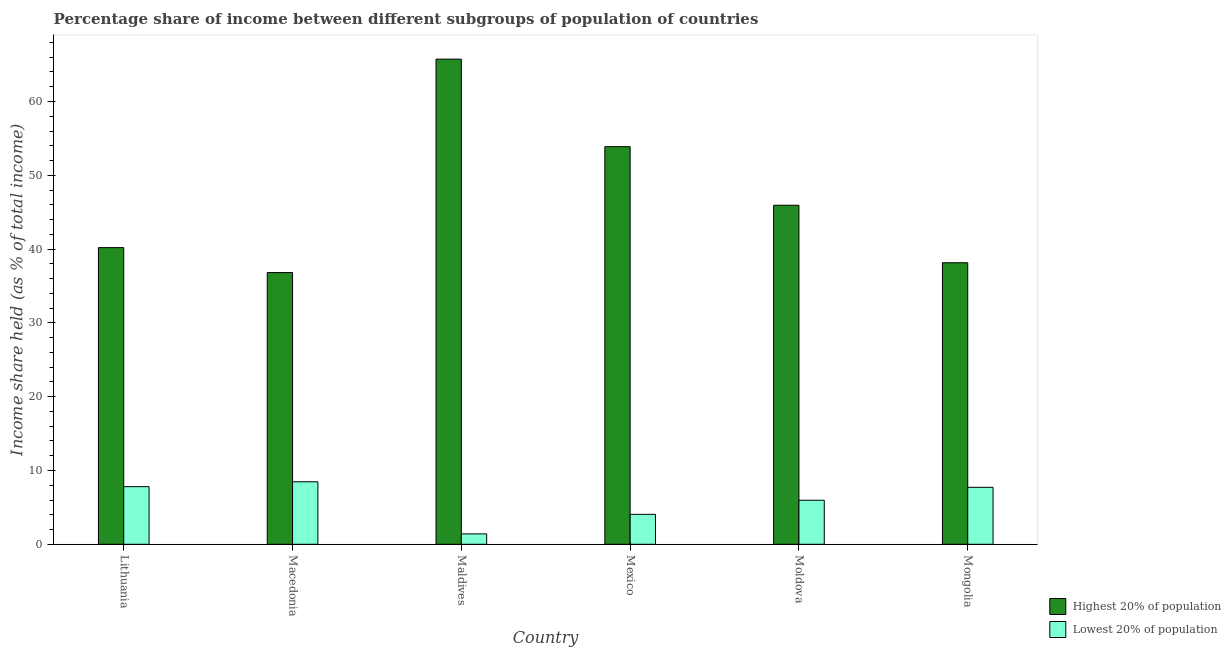How many different coloured bars are there?
Your answer should be very brief. 2. Are the number of bars on each tick of the X-axis equal?
Your answer should be very brief. Yes. How many bars are there on the 1st tick from the left?
Your answer should be very brief. 2. What is the label of the 3rd group of bars from the left?
Provide a succinct answer. Maldives. In how many cases, is the number of bars for a given country not equal to the number of legend labels?
Give a very brief answer. 0. What is the income share held by lowest 20% of the population in Macedonia?
Your answer should be very brief. 8.47. Across all countries, what is the maximum income share held by highest 20% of the population?
Offer a very short reply. 65.74. Across all countries, what is the minimum income share held by highest 20% of the population?
Your answer should be compact. 36.82. In which country was the income share held by lowest 20% of the population maximum?
Your answer should be very brief. Macedonia. In which country was the income share held by highest 20% of the population minimum?
Ensure brevity in your answer.  Macedonia. What is the total income share held by highest 20% of the population in the graph?
Make the answer very short. 280.73. What is the difference between the income share held by lowest 20% of the population in Maldives and that in Moldova?
Provide a short and direct response. -4.56. What is the difference between the income share held by lowest 20% of the population in Mexico and the income share held by highest 20% of the population in Macedonia?
Offer a terse response. -32.76. What is the average income share held by lowest 20% of the population per country?
Keep it short and to the point. 5.91. What is the difference between the income share held by lowest 20% of the population and income share held by highest 20% of the population in Mexico?
Keep it short and to the point. -49.82. What is the ratio of the income share held by highest 20% of the population in Lithuania to that in Moldova?
Ensure brevity in your answer.  0.88. Is the difference between the income share held by highest 20% of the population in Macedonia and Mexico greater than the difference between the income share held by lowest 20% of the population in Macedonia and Mexico?
Provide a succinct answer. No. What is the difference between the highest and the second highest income share held by highest 20% of the population?
Give a very brief answer. 11.86. What is the difference between the highest and the lowest income share held by highest 20% of the population?
Your answer should be compact. 28.92. In how many countries, is the income share held by highest 20% of the population greater than the average income share held by highest 20% of the population taken over all countries?
Ensure brevity in your answer.  2. What does the 1st bar from the left in Macedonia represents?
Provide a short and direct response. Highest 20% of population. What does the 1st bar from the right in Mexico represents?
Ensure brevity in your answer.  Lowest 20% of population. Are the values on the major ticks of Y-axis written in scientific E-notation?
Provide a succinct answer. No. Does the graph contain grids?
Offer a very short reply. No. Where does the legend appear in the graph?
Give a very brief answer. Bottom right. What is the title of the graph?
Offer a terse response. Percentage share of income between different subgroups of population of countries. Does "Quasi money growth" appear as one of the legend labels in the graph?
Ensure brevity in your answer.  No. What is the label or title of the X-axis?
Give a very brief answer. Country. What is the label or title of the Y-axis?
Give a very brief answer. Income share held (as % of total income). What is the Income share held (as % of total income) in Highest 20% of population in Lithuania?
Offer a terse response. 40.2. What is the Income share held (as % of total income) of Lowest 20% of population in Lithuania?
Give a very brief answer. 7.81. What is the Income share held (as % of total income) of Highest 20% of population in Macedonia?
Give a very brief answer. 36.82. What is the Income share held (as % of total income) of Lowest 20% of population in Macedonia?
Give a very brief answer. 8.47. What is the Income share held (as % of total income) in Highest 20% of population in Maldives?
Provide a short and direct response. 65.74. What is the Income share held (as % of total income) of Lowest 20% of population in Maldives?
Your answer should be very brief. 1.41. What is the Income share held (as % of total income) in Highest 20% of population in Mexico?
Offer a terse response. 53.88. What is the Income share held (as % of total income) in Lowest 20% of population in Mexico?
Your answer should be compact. 4.06. What is the Income share held (as % of total income) of Highest 20% of population in Moldova?
Keep it short and to the point. 45.94. What is the Income share held (as % of total income) in Lowest 20% of population in Moldova?
Your answer should be compact. 5.97. What is the Income share held (as % of total income) of Highest 20% of population in Mongolia?
Your answer should be very brief. 38.15. What is the Income share held (as % of total income) of Lowest 20% of population in Mongolia?
Make the answer very short. 7.72. Across all countries, what is the maximum Income share held (as % of total income) in Highest 20% of population?
Make the answer very short. 65.74. Across all countries, what is the maximum Income share held (as % of total income) in Lowest 20% of population?
Keep it short and to the point. 8.47. Across all countries, what is the minimum Income share held (as % of total income) of Highest 20% of population?
Make the answer very short. 36.82. Across all countries, what is the minimum Income share held (as % of total income) of Lowest 20% of population?
Provide a short and direct response. 1.41. What is the total Income share held (as % of total income) of Highest 20% of population in the graph?
Offer a very short reply. 280.73. What is the total Income share held (as % of total income) in Lowest 20% of population in the graph?
Provide a short and direct response. 35.44. What is the difference between the Income share held (as % of total income) of Highest 20% of population in Lithuania and that in Macedonia?
Your response must be concise. 3.38. What is the difference between the Income share held (as % of total income) in Lowest 20% of population in Lithuania and that in Macedonia?
Your answer should be compact. -0.66. What is the difference between the Income share held (as % of total income) of Highest 20% of population in Lithuania and that in Maldives?
Your response must be concise. -25.54. What is the difference between the Income share held (as % of total income) in Lowest 20% of population in Lithuania and that in Maldives?
Give a very brief answer. 6.4. What is the difference between the Income share held (as % of total income) of Highest 20% of population in Lithuania and that in Mexico?
Your answer should be compact. -13.68. What is the difference between the Income share held (as % of total income) in Lowest 20% of population in Lithuania and that in Mexico?
Your answer should be compact. 3.75. What is the difference between the Income share held (as % of total income) of Highest 20% of population in Lithuania and that in Moldova?
Make the answer very short. -5.74. What is the difference between the Income share held (as % of total income) of Lowest 20% of population in Lithuania and that in Moldova?
Provide a succinct answer. 1.84. What is the difference between the Income share held (as % of total income) in Highest 20% of population in Lithuania and that in Mongolia?
Keep it short and to the point. 2.05. What is the difference between the Income share held (as % of total income) in Lowest 20% of population in Lithuania and that in Mongolia?
Your response must be concise. 0.09. What is the difference between the Income share held (as % of total income) of Highest 20% of population in Macedonia and that in Maldives?
Ensure brevity in your answer.  -28.92. What is the difference between the Income share held (as % of total income) in Lowest 20% of population in Macedonia and that in Maldives?
Your answer should be compact. 7.06. What is the difference between the Income share held (as % of total income) in Highest 20% of population in Macedonia and that in Mexico?
Ensure brevity in your answer.  -17.06. What is the difference between the Income share held (as % of total income) in Lowest 20% of population in Macedonia and that in Mexico?
Keep it short and to the point. 4.41. What is the difference between the Income share held (as % of total income) in Highest 20% of population in Macedonia and that in Moldova?
Offer a very short reply. -9.12. What is the difference between the Income share held (as % of total income) in Lowest 20% of population in Macedonia and that in Moldova?
Ensure brevity in your answer.  2.5. What is the difference between the Income share held (as % of total income) of Highest 20% of population in Macedonia and that in Mongolia?
Give a very brief answer. -1.33. What is the difference between the Income share held (as % of total income) of Lowest 20% of population in Macedonia and that in Mongolia?
Offer a terse response. 0.75. What is the difference between the Income share held (as % of total income) in Highest 20% of population in Maldives and that in Mexico?
Make the answer very short. 11.86. What is the difference between the Income share held (as % of total income) of Lowest 20% of population in Maldives and that in Mexico?
Ensure brevity in your answer.  -2.65. What is the difference between the Income share held (as % of total income) in Highest 20% of population in Maldives and that in Moldova?
Your answer should be very brief. 19.8. What is the difference between the Income share held (as % of total income) in Lowest 20% of population in Maldives and that in Moldova?
Provide a succinct answer. -4.56. What is the difference between the Income share held (as % of total income) in Highest 20% of population in Maldives and that in Mongolia?
Provide a short and direct response. 27.59. What is the difference between the Income share held (as % of total income) in Lowest 20% of population in Maldives and that in Mongolia?
Give a very brief answer. -6.31. What is the difference between the Income share held (as % of total income) in Highest 20% of population in Mexico and that in Moldova?
Your answer should be very brief. 7.94. What is the difference between the Income share held (as % of total income) in Lowest 20% of population in Mexico and that in Moldova?
Your response must be concise. -1.91. What is the difference between the Income share held (as % of total income) in Highest 20% of population in Mexico and that in Mongolia?
Ensure brevity in your answer.  15.73. What is the difference between the Income share held (as % of total income) in Lowest 20% of population in Mexico and that in Mongolia?
Your answer should be very brief. -3.66. What is the difference between the Income share held (as % of total income) of Highest 20% of population in Moldova and that in Mongolia?
Ensure brevity in your answer.  7.79. What is the difference between the Income share held (as % of total income) in Lowest 20% of population in Moldova and that in Mongolia?
Your answer should be very brief. -1.75. What is the difference between the Income share held (as % of total income) of Highest 20% of population in Lithuania and the Income share held (as % of total income) of Lowest 20% of population in Macedonia?
Ensure brevity in your answer.  31.73. What is the difference between the Income share held (as % of total income) of Highest 20% of population in Lithuania and the Income share held (as % of total income) of Lowest 20% of population in Maldives?
Ensure brevity in your answer.  38.79. What is the difference between the Income share held (as % of total income) in Highest 20% of population in Lithuania and the Income share held (as % of total income) in Lowest 20% of population in Mexico?
Your response must be concise. 36.14. What is the difference between the Income share held (as % of total income) of Highest 20% of population in Lithuania and the Income share held (as % of total income) of Lowest 20% of population in Moldova?
Keep it short and to the point. 34.23. What is the difference between the Income share held (as % of total income) of Highest 20% of population in Lithuania and the Income share held (as % of total income) of Lowest 20% of population in Mongolia?
Provide a succinct answer. 32.48. What is the difference between the Income share held (as % of total income) in Highest 20% of population in Macedonia and the Income share held (as % of total income) in Lowest 20% of population in Maldives?
Offer a very short reply. 35.41. What is the difference between the Income share held (as % of total income) in Highest 20% of population in Macedonia and the Income share held (as % of total income) in Lowest 20% of population in Mexico?
Your response must be concise. 32.76. What is the difference between the Income share held (as % of total income) of Highest 20% of population in Macedonia and the Income share held (as % of total income) of Lowest 20% of population in Moldova?
Give a very brief answer. 30.85. What is the difference between the Income share held (as % of total income) in Highest 20% of population in Macedonia and the Income share held (as % of total income) in Lowest 20% of population in Mongolia?
Offer a terse response. 29.1. What is the difference between the Income share held (as % of total income) in Highest 20% of population in Maldives and the Income share held (as % of total income) in Lowest 20% of population in Mexico?
Offer a terse response. 61.68. What is the difference between the Income share held (as % of total income) of Highest 20% of population in Maldives and the Income share held (as % of total income) of Lowest 20% of population in Moldova?
Ensure brevity in your answer.  59.77. What is the difference between the Income share held (as % of total income) of Highest 20% of population in Maldives and the Income share held (as % of total income) of Lowest 20% of population in Mongolia?
Make the answer very short. 58.02. What is the difference between the Income share held (as % of total income) in Highest 20% of population in Mexico and the Income share held (as % of total income) in Lowest 20% of population in Moldova?
Give a very brief answer. 47.91. What is the difference between the Income share held (as % of total income) in Highest 20% of population in Mexico and the Income share held (as % of total income) in Lowest 20% of population in Mongolia?
Your answer should be compact. 46.16. What is the difference between the Income share held (as % of total income) in Highest 20% of population in Moldova and the Income share held (as % of total income) in Lowest 20% of population in Mongolia?
Ensure brevity in your answer.  38.22. What is the average Income share held (as % of total income) in Highest 20% of population per country?
Offer a very short reply. 46.79. What is the average Income share held (as % of total income) in Lowest 20% of population per country?
Ensure brevity in your answer.  5.91. What is the difference between the Income share held (as % of total income) of Highest 20% of population and Income share held (as % of total income) of Lowest 20% of population in Lithuania?
Make the answer very short. 32.39. What is the difference between the Income share held (as % of total income) of Highest 20% of population and Income share held (as % of total income) of Lowest 20% of population in Macedonia?
Ensure brevity in your answer.  28.35. What is the difference between the Income share held (as % of total income) in Highest 20% of population and Income share held (as % of total income) in Lowest 20% of population in Maldives?
Your answer should be very brief. 64.33. What is the difference between the Income share held (as % of total income) in Highest 20% of population and Income share held (as % of total income) in Lowest 20% of population in Mexico?
Give a very brief answer. 49.82. What is the difference between the Income share held (as % of total income) in Highest 20% of population and Income share held (as % of total income) in Lowest 20% of population in Moldova?
Offer a terse response. 39.97. What is the difference between the Income share held (as % of total income) in Highest 20% of population and Income share held (as % of total income) in Lowest 20% of population in Mongolia?
Provide a succinct answer. 30.43. What is the ratio of the Income share held (as % of total income) of Highest 20% of population in Lithuania to that in Macedonia?
Ensure brevity in your answer.  1.09. What is the ratio of the Income share held (as % of total income) of Lowest 20% of population in Lithuania to that in Macedonia?
Make the answer very short. 0.92. What is the ratio of the Income share held (as % of total income) of Highest 20% of population in Lithuania to that in Maldives?
Keep it short and to the point. 0.61. What is the ratio of the Income share held (as % of total income) of Lowest 20% of population in Lithuania to that in Maldives?
Your response must be concise. 5.54. What is the ratio of the Income share held (as % of total income) of Highest 20% of population in Lithuania to that in Mexico?
Your answer should be compact. 0.75. What is the ratio of the Income share held (as % of total income) of Lowest 20% of population in Lithuania to that in Mexico?
Make the answer very short. 1.92. What is the ratio of the Income share held (as % of total income) of Highest 20% of population in Lithuania to that in Moldova?
Give a very brief answer. 0.88. What is the ratio of the Income share held (as % of total income) in Lowest 20% of population in Lithuania to that in Moldova?
Provide a short and direct response. 1.31. What is the ratio of the Income share held (as % of total income) in Highest 20% of population in Lithuania to that in Mongolia?
Your answer should be compact. 1.05. What is the ratio of the Income share held (as % of total income) in Lowest 20% of population in Lithuania to that in Mongolia?
Provide a short and direct response. 1.01. What is the ratio of the Income share held (as % of total income) in Highest 20% of population in Macedonia to that in Maldives?
Provide a short and direct response. 0.56. What is the ratio of the Income share held (as % of total income) of Lowest 20% of population in Macedonia to that in Maldives?
Your response must be concise. 6.01. What is the ratio of the Income share held (as % of total income) in Highest 20% of population in Macedonia to that in Mexico?
Your answer should be very brief. 0.68. What is the ratio of the Income share held (as % of total income) in Lowest 20% of population in Macedonia to that in Mexico?
Offer a very short reply. 2.09. What is the ratio of the Income share held (as % of total income) in Highest 20% of population in Macedonia to that in Moldova?
Your answer should be very brief. 0.8. What is the ratio of the Income share held (as % of total income) in Lowest 20% of population in Macedonia to that in Moldova?
Your answer should be very brief. 1.42. What is the ratio of the Income share held (as % of total income) in Highest 20% of population in Macedonia to that in Mongolia?
Your response must be concise. 0.97. What is the ratio of the Income share held (as % of total income) in Lowest 20% of population in Macedonia to that in Mongolia?
Make the answer very short. 1.1. What is the ratio of the Income share held (as % of total income) of Highest 20% of population in Maldives to that in Mexico?
Your answer should be compact. 1.22. What is the ratio of the Income share held (as % of total income) in Lowest 20% of population in Maldives to that in Mexico?
Offer a very short reply. 0.35. What is the ratio of the Income share held (as % of total income) in Highest 20% of population in Maldives to that in Moldova?
Give a very brief answer. 1.43. What is the ratio of the Income share held (as % of total income) of Lowest 20% of population in Maldives to that in Moldova?
Your answer should be very brief. 0.24. What is the ratio of the Income share held (as % of total income) of Highest 20% of population in Maldives to that in Mongolia?
Your answer should be compact. 1.72. What is the ratio of the Income share held (as % of total income) in Lowest 20% of population in Maldives to that in Mongolia?
Provide a short and direct response. 0.18. What is the ratio of the Income share held (as % of total income) in Highest 20% of population in Mexico to that in Moldova?
Your answer should be compact. 1.17. What is the ratio of the Income share held (as % of total income) in Lowest 20% of population in Mexico to that in Moldova?
Make the answer very short. 0.68. What is the ratio of the Income share held (as % of total income) in Highest 20% of population in Mexico to that in Mongolia?
Provide a succinct answer. 1.41. What is the ratio of the Income share held (as % of total income) in Lowest 20% of population in Mexico to that in Mongolia?
Ensure brevity in your answer.  0.53. What is the ratio of the Income share held (as % of total income) in Highest 20% of population in Moldova to that in Mongolia?
Provide a succinct answer. 1.2. What is the ratio of the Income share held (as % of total income) of Lowest 20% of population in Moldova to that in Mongolia?
Provide a succinct answer. 0.77. What is the difference between the highest and the second highest Income share held (as % of total income) of Highest 20% of population?
Give a very brief answer. 11.86. What is the difference between the highest and the second highest Income share held (as % of total income) in Lowest 20% of population?
Your answer should be compact. 0.66. What is the difference between the highest and the lowest Income share held (as % of total income) of Highest 20% of population?
Provide a short and direct response. 28.92. What is the difference between the highest and the lowest Income share held (as % of total income) of Lowest 20% of population?
Offer a terse response. 7.06. 